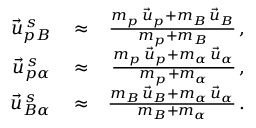Convert formula to latex. <formula><loc_0><loc_0><loc_500><loc_500>\begin{array} { r l r } { \vec { u } _ { p B } ^ { \, s } } & \approx } & { \frac { m _ { p } \, \vec { u } _ { p } + m _ { B } \, \vec { u } _ { B } } { m _ { p } + m _ { B } } \, , } \\ { \vec { u } _ { p \alpha } ^ { \, s } } & \approx } & { \frac { m _ { p } \, \vec { u } _ { p } + m _ { \alpha } \, \vec { u } _ { \alpha } } { m _ { p } + m _ { \alpha } } \, , } \\ { \vec { u } _ { B \alpha } ^ { \, s } } & \approx } & { \frac { m _ { B } \, \vec { u } _ { B } + m _ { \alpha } \, \vec { u } _ { \alpha } } { m _ { B } + m _ { \alpha } } \, . } \end{array}</formula> 